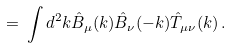Convert formula to latex. <formula><loc_0><loc_0><loc_500><loc_500>= \, \int d ^ { 2 } k \hat { B } _ { \mu } ( k ) \hat { B } _ { \nu } ( - k ) \hat { T } _ { \mu \nu } ( k ) \, .</formula> 